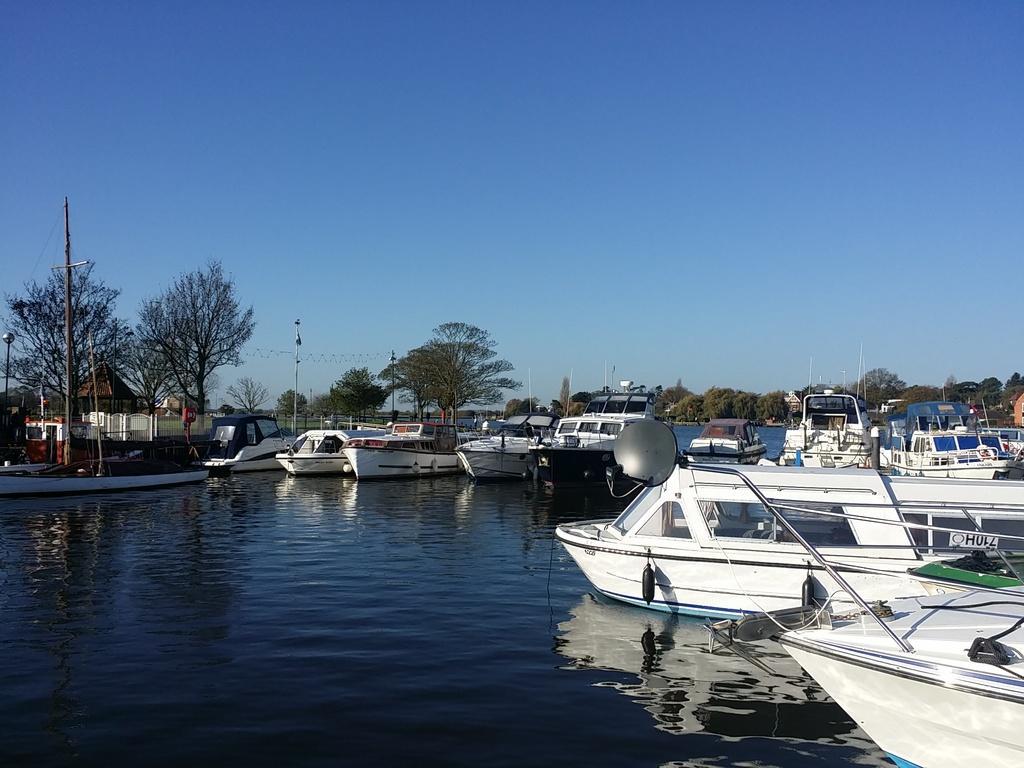Please provide a concise description of this image. These are the boats, which are on the water. I can see the trees. This looks like a current pole. I think this is a small kind of house. Here is the sky. 